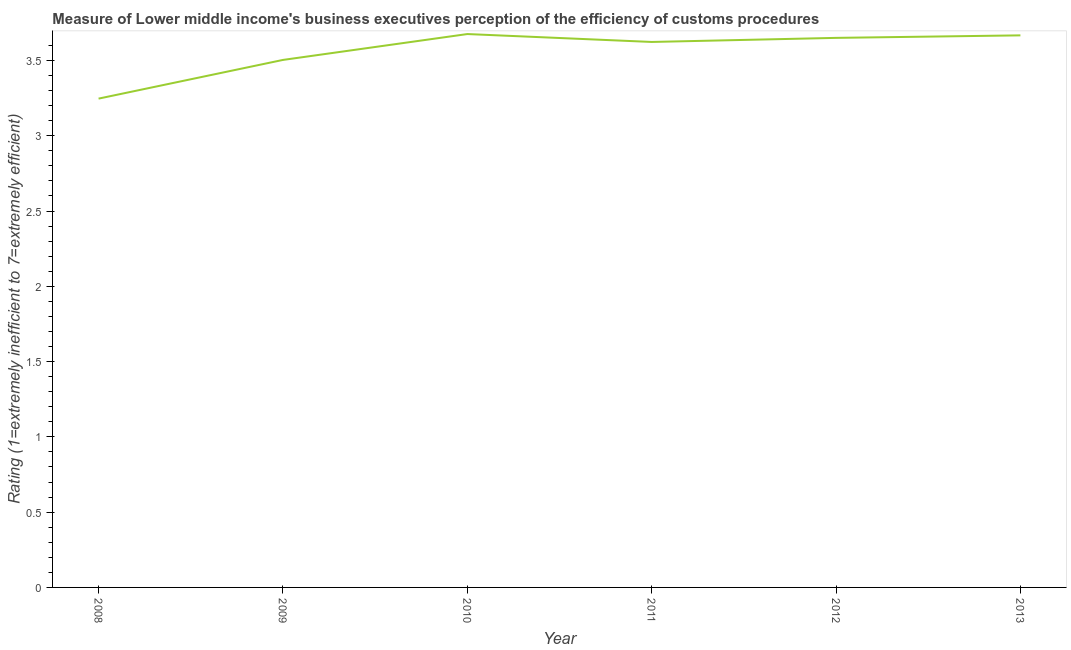What is the rating measuring burden of customs procedure in 2011?
Offer a terse response. 3.62. Across all years, what is the maximum rating measuring burden of customs procedure?
Provide a short and direct response. 3.68. Across all years, what is the minimum rating measuring burden of customs procedure?
Offer a terse response. 3.25. What is the sum of the rating measuring burden of customs procedure?
Your answer should be very brief. 21.36. What is the difference between the rating measuring burden of customs procedure in 2008 and 2012?
Offer a very short reply. -0.4. What is the average rating measuring burden of customs procedure per year?
Give a very brief answer. 3.56. What is the median rating measuring burden of customs procedure?
Make the answer very short. 3.64. In how many years, is the rating measuring burden of customs procedure greater than 3.2 ?
Offer a very short reply. 6. Do a majority of the years between 2013 and 2012 (inclusive) have rating measuring burden of customs procedure greater than 2.8 ?
Ensure brevity in your answer.  No. What is the ratio of the rating measuring burden of customs procedure in 2011 to that in 2012?
Offer a terse response. 0.99. Is the rating measuring burden of customs procedure in 2008 less than that in 2011?
Make the answer very short. Yes. Is the difference between the rating measuring burden of customs procedure in 2008 and 2009 greater than the difference between any two years?
Ensure brevity in your answer.  No. What is the difference between the highest and the second highest rating measuring burden of customs procedure?
Give a very brief answer. 0.01. What is the difference between the highest and the lowest rating measuring burden of customs procedure?
Keep it short and to the point. 0.43. What is the difference between two consecutive major ticks on the Y-axis?
Offer a very short reply. 0.5. Are the values on the major ticks of Y-axis written in scientific E-notation?
Provide a succinct answer. No. What is the title of the graph?
Offer a terse response. Measure of Lower middle income's business executives perception of the efficiency of customs procedures. What is the label or title of the X-axis?
Your answer should be compact. Year. What is the label or title of the Y-axis?
Keep it short and to the point. Rating (1=extremely inefficient to 7=extremely efficient). What is the Rating (1=extremely inefficient to 7=extremely efficient) of 2008?
Keep it short and to the point. 3.25. What is the Rating (1=extremely inefficient to 7=extremely efficient) in 2009?
Give a very brief answer. 3.5. What is the Rating (1=extremely inefficient to 7=extremely efficient) of 2010?
Your response must be concise. 3.68. What is the Rating (1=extremely inefficient to 7=extremely efficient) of 2011?
Your answer should be compact. 3.62. What is the Rating (1=extremely inefficient to 7=extremely efficient) in 2012?
Your answer should be very brief. 3.65. What is the Rating (1=extremely inefficient to 7=extremely efficient) in 2013?
Keep it short and to the point. 3.67. What is the difference between the Rating (1=extremely inefficient to 7=extremely efficient) in 2008 and 2009?
Your answer should be very brief. -0.26. What is the difference between the Rating (1=extremely inefficient to 7=extremely efficient) in 2008 and 2010?
Your answer should be compact. -0.43. What is the difference between the Rating (1=extremely inefficient to 7=extremely efficient) in 2008 and 2011?
Keep it short and to the point. -0.38. What is the difference between the Rating (1=extremely inefficient to 7=extremely efficient) in 2008 and 2012?
Keep it short and to the point. -0.4. What is the difference between the Rating (1=extremely inefficient to 7=extremely efficient) in 2008 and 2013?
Keep it short and to the point. -0.42. What is the difference between the Rating (1=extremely inefficient to 7=extremely efficient) in 2009 and 2010?
Offer a very short reply. -0.17. What is the difference between the Rating (1=extremely inefficient to 7=extremely efficient) in 2009 and 2011?
Offer a terse response. -0.12. What is the difference between the Rating (1=extremely inefficient to 7=extremely efficient) in 2009 and 2012?
Provide a succinct answer. -0.15. What is the difference between the Rating (1=extremely inefficient to 7=extremely efficient) in 2009 and 2013?
Offer a terse response. -0.16. What is the difference between the Rating (1=extremely inefficient to 7=extremely efficient) in 2010 and 2011?
Your answer should be very brief. 0.05. What is the difference between the Rating (1=extremely inefficient to 7=extremely efficient) in 2010 and 2012?
Ensure brevity in your answer.  0.03. What is the difference between the Rating (1=extremely inefficient to 7=extremely efficient) in 2010 and 2013?
Ensure brevity in your answer.  0.01. What is the difference between the Rating (1=extremely inefficient to 7=extremely efficient) in 2011 and 2012?
Your response must be concise. -0.03. What is the difference between the Rating (1=extremely inefficient to 7=extremely efficient) in 2011 and 2013?
Keep it short and to the point. -0.04. What is the difference between the Rating (1=extremely inefficient to 7=extremely efficient) in 2012 and 2013?
Provide a succinct answer. -0.02. What is the ratio of the Rating (1=extremely inefficient to 7=extremely efficient) in 2008 to that in 2009?
Keep it short and to the point. 0.93. What is the ratio of the Rating (1=extremely inefficient to 7=extremely efficient) in 2008 to that in 2010?
Provide a succinct answer. 0.88. What is the ratio of the Rating (1=extremely inefficient to 7=extremely efficient) in 2008 to that in 2011?
Give a very brief answer. 0.9. What is the ratio of the Rating (1=extremely inefficient to 7=extremely efficient) in 2008 to that in 2012?
Give a very brief answer. 0.89. What is the ratio of the Rating (1=extremely inefficient to 7=extremely efficient) in 2008 to that in 2013?
Make the answer very short. 0.89. What is the ratio of the Rating (1=extremely inefficient to 7=extremely efficient) in 2009 to that in 2010?
Ensure brevity in your answer.  0.95. What is the ratio of the Rating (1=extremely inefficient to 7=extremely efficient) in 2009 to that in 2011?
Keep it short and to the point. 0.97. What is the ratio of the Rating (1=extremely inefficient to 7=extremely efficient) in 2009 to that in 2013?
Give a very brief answer. 0.95. What is the ratio of the Rating (1=extremely inefficient to 7=extremely efficient) in 2010 to that in 2011?
Keep it short and to the point. 1.01. What is the ratio of the Rating (1=extremely inefficient to 7=extremely efficient) in 2010 to that in 2013?
Provide a short and direct response. 1. 